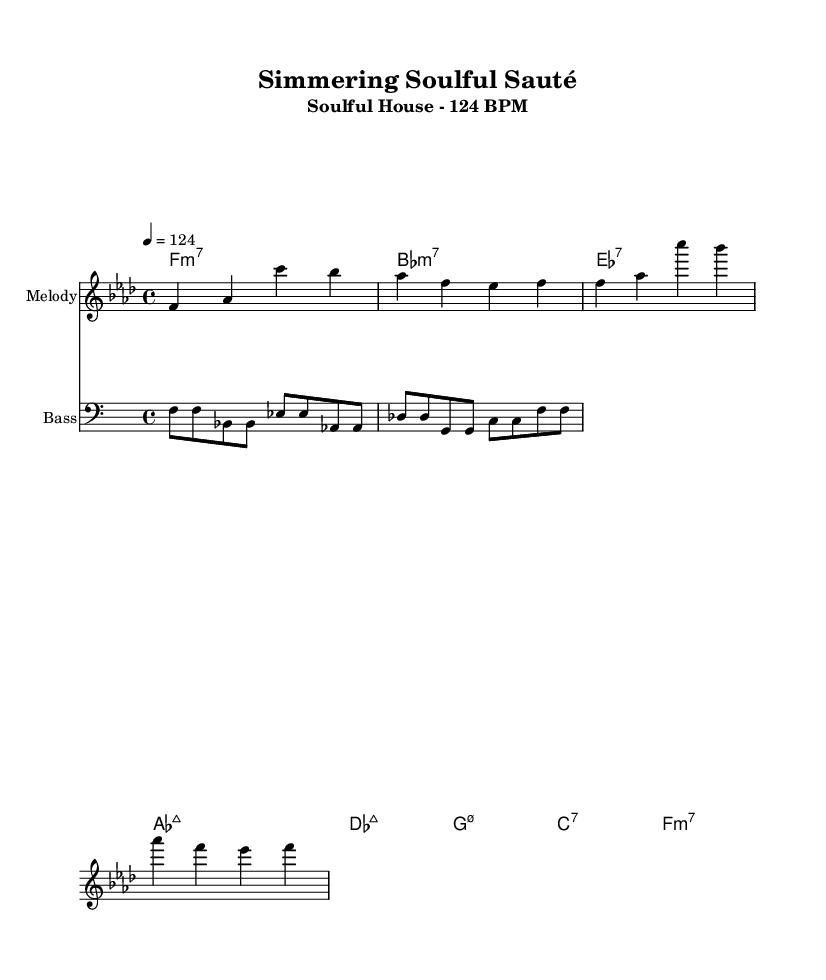What is the key signature of this music? The key signature shown in the music indicates F minor, which has four flats (B, E, A, D). The key signature is typically identified at the beginning of the staff.
Answer: F minor What is the time signature of this music? The time signature is located at the beginning of the staff next to the key signature. Here it shows 4/4, which means there are 4 beats in each measure and the quarter note receives one beat.
Answer: 4/4 What is the tempo marking for this piece? The tempo marking appears below the time signature and indicates the speed of the music. In this case, it indicates to play at 124 beats per minute, giving a sense of the piece's energetic pace.
Answer: 124 How many measures are there in the melody? To determine the number of measures, you can count the segments separated by bar lines in the melody staff. In this case, there are 4 measures in total.
Answer: 4 What type of seventh chord is the first harmony? The first harmony listed is F minor 7, which is indicated by the chord symbol "f1:m7". This indicates that the chord includes the root F, minor third A flat, perfect fifth C, and minor seventh E flat.
Answer: F minor 7 What is the instrument used for the bassline? The instrument for the bassline is labeled as "Bass" in the music sheet. This provides context on which instrument is playing this part.
Answer: Bass What musical genre does this piece belong to? The genre of this piece is indicated in the subtitle "Soulful House," which describes the style of music being played, known for its uplifting feel and deep rhythms.
Answer: Soulful House 